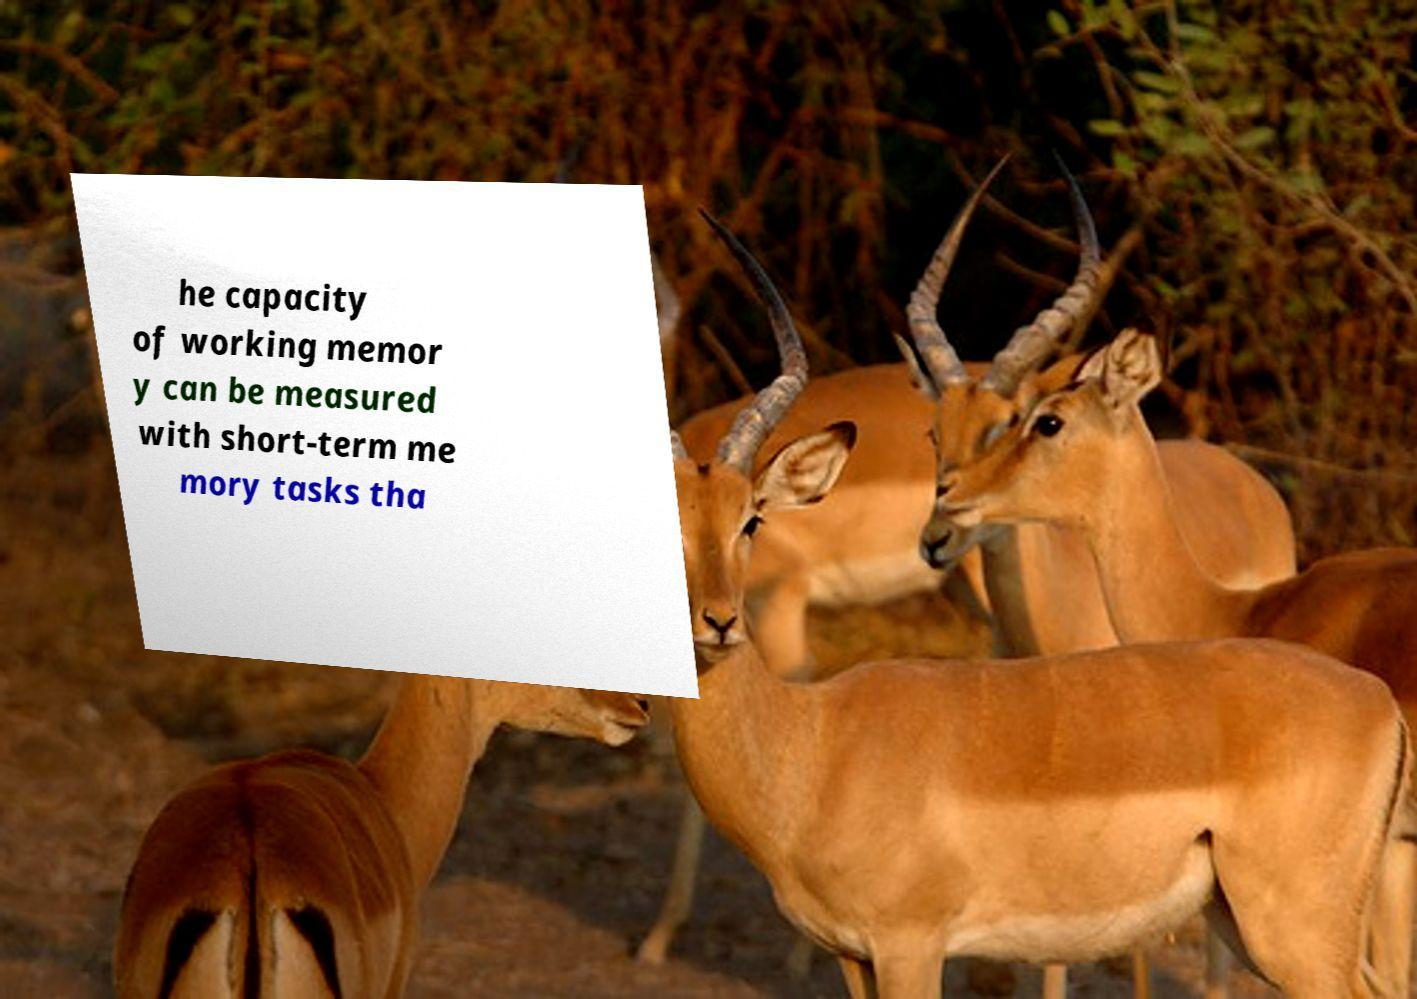Could you extract and type out the text from this image? he capacity of working memor y can be measured with short-term me mory tasks tha 